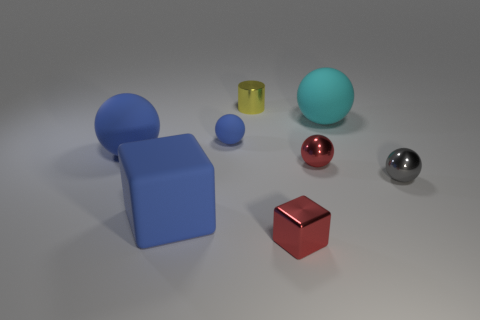Subtract all blue cylinders. How many blue spheres are left? 2 Subtract all cyan matte spheres. How many spheres are left? 4 Subtract 2 balls. How many balls are left? 3 Subtract all gray spheres. How many spheres are left? 4 Add 1 cyan matte things. How many objects exist? 9 Subtract all blue spheres. Subtract all red cubes. How many spheres are left? 3 Subtract all balls. How many objects are left? 3 Subtract all big brown rubber spheres. Subtract all large blue matte blocks. How many objects are left? 7 Add 8 small matte spheres. How many small matte spheres are left? 9 Add 7 small yellow shiny objects. How many small yellow shiny objects exist? 8 